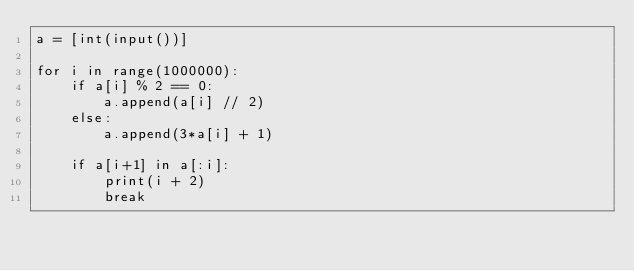Convert code to text. <code><loc_0><loc_0><loc_500><loc_500><_Python_>a = [int(input())]

for i in range(1000000):
    if a[i] % 2 == 0:
        a.append(a[i] // 2)
    else:
        a.append(3*a[i] + 1)
    
    if a[i+1] in a[:i]:
        print(i + 2)
        break</code> 